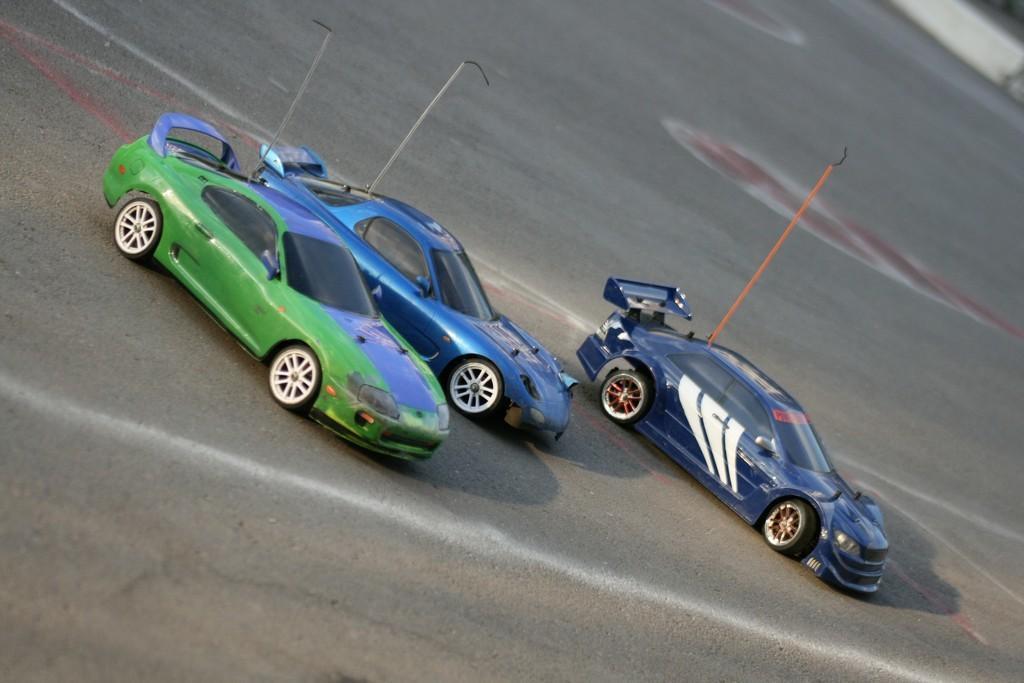In one or two sentences, can you explain what this image depicts? In the image we can see there are three racing cars parked on the road. 